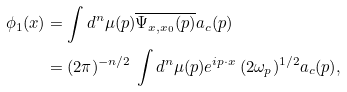Convert formula to latex. <formula><loc_0><loc_0><loc_500><loc_500>\phi _ { 1 } ( { x } ) & = \int d ^ { n } \mu ( p ) \overline { \Psi _ { x , x _ { 0 } } ( p ) } a _ { c } ( p ) \\ & = ( 2 \pi ) ^ { - n / 2 } \, \int d ^ { n } \mu ( p ) e ^ { i { p } \cdot { x } } \, ( 2 \omega _ { p } ) ^ { 1 / 2 } a _ { c } ( p ) ,</formula> 